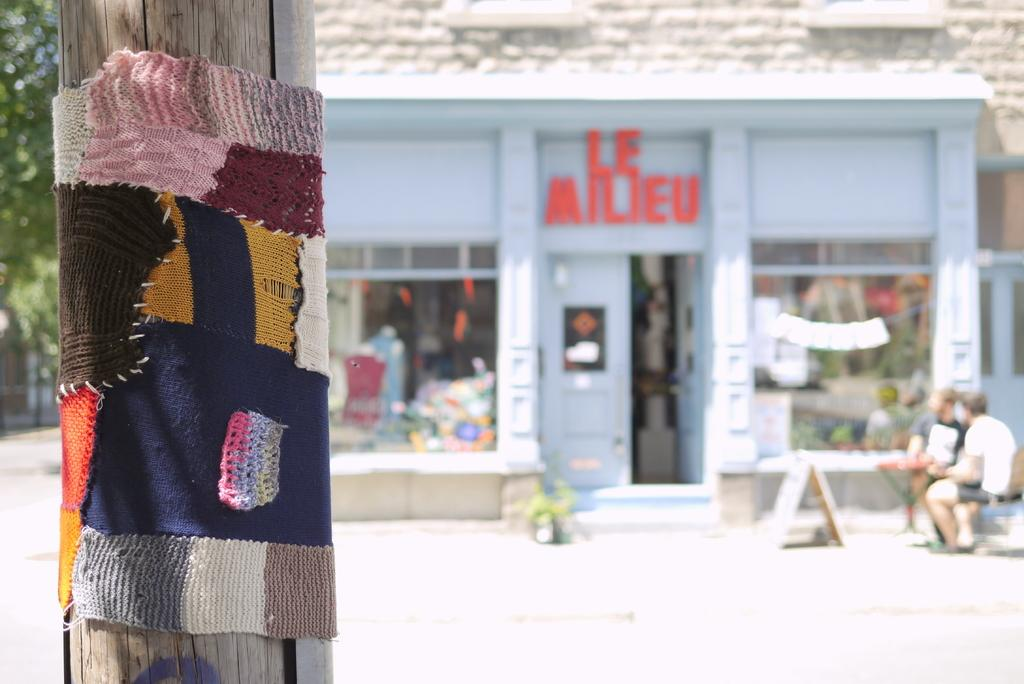What is tied to the wooden pole in the image? There is a cloth tied to a wooden pole in the image. What can be seen in the background of the image? There is a building in the background of the image. Where are the people sitting in the image? The people are sitting in the right side corner of the image. What type of vegetation is on the left side of the image? There is a tree on the left side of the image. What type of clouds can be seen in the image? There are no clouds present in the image. What material is the coach made of in the image? There is no coach present in the image. 